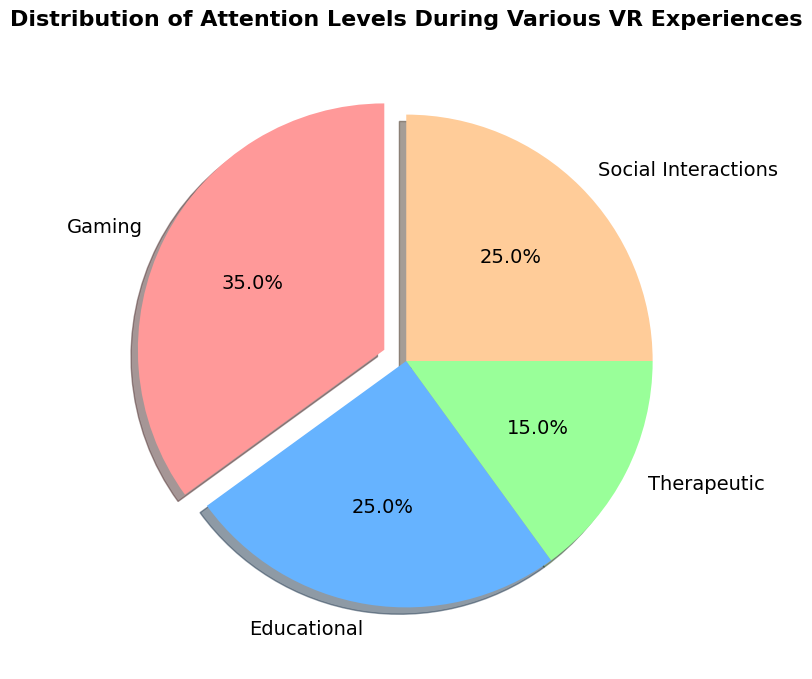What category of VR experience has the highest attention level? Gaming has the highest attention level according to the pie chart, where it stands out with a larger portion of the pie and an "explode" effect used to emphasize its importance.
Answer: Gaming Which VR experiences have equal attention levels? The sectors labeled "Educational" and "Social Interactions" both take up equal portions of the pie chart, meaning they share the same attention level.
Answer: Educational and Social Interactions How much more attention does Gaming receive compared to Therapeutic experiences? Gaming receives 35% attention and Therapeutic experiences receive 15%. Computing the difference: 35% - 15% = 20%.
Answer: 20% What is the combined percentage of attention levels for Educational and Social Interactions categories? Both Educational and Social Interactions categories each hold 25% of attention. Adding these gives: 25% + 25% = 50%.
Answer: 50% Describe the visual difference between the Gaming section and the other sections in the pie chart. The Gaming section of the pie chart is "exploded," meaning it is slightly separated from the center, and it is larger in size than any other section, making it visually distinct.
Answer: Exploded and larger What color represents the Therapeutic category in the pie chart? The pie chart segment for the Therapeutic category is represented in a shade of green.
Answer: Green If you exclude Gaming, what is the average attention level of the remaining three categories? The attention levels for the remaining categories are Educational (25%), Therapeutic (15%), and Social Interactions (25%). Calculating the average: (25% + 15% + 25%) / 3 = 65% / 3 ≈ 21.7%.
Answer: 21.7% Compare the attention given to Educational experiences with that of Gaming and conclude which has greater attention. Gaming has 35% attention while Educational experiences have 25%. Since 25% is less than 35%, Gaming has greater attention.
Answer: Gaming What is the percentage difference in attention between Social Interactions and Therapeutic experiences? Social Interactions receive 25% attention while Therapeutic experiences receive 15%. Calculating the percentage difference: 25% - 15% = 10%.
Answer: 10% Which category is closest in attention level to the Therapeutic category? Among the remaining categories, Educational and Social Interactions have 25% attention each. Both are equally closer to the Therapeutic category which has 15% attention.
Answer: Educational and Social Interactions 